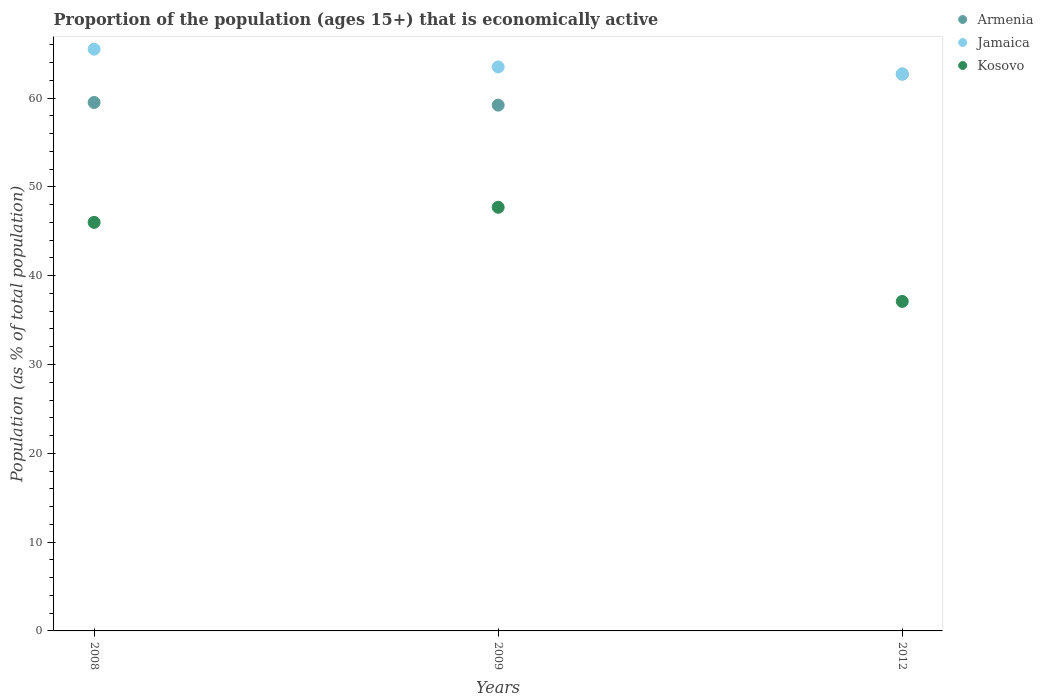What is the proportion of the population that is economically active in Armenia in 2012?
Offer a very short reply. 62.7. Across all years, what is the maximum proportion of the population that is economically active in Jamaica?
Your response must be concise. 65.5. Across all years, what is the minimum proportion of the population that is economically active in Kosovo?
Make the answer very short. 37.1. In which year was the proportion of the population that is economically active in Jamaica maximum?
Keep it short and to the point. 2008. What is the total proportion of the population that is economically active in Jamaica in the graph?
Ensure brevity in your answer.  191.7. What is the difference between the proportion of the population that is economically active in Kosovo in 2008 and that in 2012?
Make the answer very short. 8.9. What is the difference between the proportion of the population that is economically active in Jamaica in 2012 and the proportion of the population that is economically active in Armenia in 2008?
Provide a short and direct response. 3.2. What is the average proportion of the population that is economically active in Armenia per year?
Provide a succinct answer. 60.47. What is the ratio of the proportion of the population that is economically active in Armenia in 2009 to that in 2012?
Make the answer very short. 0.94. Is the proportion of the population that is economically active in Kosovo in 2008 less than that in 2009?
Make the answer very short. Yes. What is the difference between the highest and the second highest proportion of the population that is economically active in Armenia?
Give a very brief answer. 3.2. What is the difference between the highest and the lowest proportion of the population that is economically active in Kosovo?
Provide a succinct answer. 10.6. Is it the case that in every year, the sum of the proportion of the population that is economically active in Armenia and proportion of the population that is economically active in Jamaica  is greater than the proportion of the population that is economically active in Kosovo?
Keep it short and to the point. Yes. Does the proportion of the population that is economically active in Kosovo monotonically increase over the years?
Offer a very short reply. No. What is the difference between two consecutive major ticks on the Y-axis?
Your answer should be very brief. 10. Are the values on the major ticks of Y-axis written in scientific E-notation?
Offer a very short reply. No. Does the graph contain any zero values?
Offer a terse response. No. How many legend labels are there?
Provide a short and direct response. 3. How are the legend labels stacked?
Your response must be concise. Vertical. What is the title of the graph?
Provide a succinct answer. Proportion of the population (ages 15+) that is economically active. What is the label or title of the Y-axis?
Give a very brief answer. Population (as % of total population). What is the Population (as % of total population) in Armenia in 2008?
Provide a succinct answer. 59.5. What is the Population (as % of total population) of Jamaica in 2008?
Offer a very short reply. 65.5. What is the Population (as % of total population) of Armenia in 2009?
Keep it short and to the point. 59.2. What is the Population (as % of total population) in Jamaica in 2009?
Ensure brevity in your answer.  63.5. What is the Population (as % of total population) of Kosovo in 2009?
Your response must be concise. 47.7. What is the Population (as % of total population) in Armenia in 2012?
Your response must be concise. 62.7. What is the Population (as % of total population) in Jamaica in 2012?
Your answer should be compact. 62.7. What is the Population (as % of total population) in Kosovo in 2012?
Ensure brevity in your answer.  37.1. Across all years, what is the maximum Population (as % of total population) of Armenia?
Your response must be concise. 62.7. Across all years, what is the maximum Population (as % of total population) of Jamaica?
Provide a succinct answer. 65.5. Across all years, what is the maximum Population (as % of total population) in Kosovo?
Offer a terse response. 47.7. Across all years, what is the minimum Population (as % of total population) in Armenia?
Your answer should be very brief. 59.2. Across all years, what is the minimum Population (as % of total population) of Jamaica?
Keep it short and to the point. 62.7. Across all years, what is the minimum Population (as % of total population) in Kosovo?
Offer a terse response. 37.1. What is the total Population (as % of total population) of Armenia in the graph?
Keep it short and to the point. 181.4. What is the total Population (as % of total population) of Jamaica in the graph?
Provide a succinct answer. 191.7. What is the total Population (as % of total population) of Kosovo in the graph?
Your answer should be compact. 130.8. What is the difference between the Population (as % of total population) in Jamaica in 2008 and that in 2009?
Keep it short and to the point. 2. What is the difference between the Population (as % of total population) of Kosovo in 2008 and that in 2009?
Provide a short and direct response. -1.7. What is the difference between the Population (as % of total population) in Armenia in 2008 and that in 2012?
Make the answer very short. -3.2. What is the difference between the Population (as % of total population) of Jamaica in 2008 and that in 2012?
Provide a succinct answer. 2.8. What is the difference between the Population (as % of total population) in Kosovo in 2008 and that in 2012?
Give a very brief answer. 8.9. What is the difference between the Population (as % of total population) in Armenia in 2009 and that in 2012?
Offer a terse response. -3.5. What is the difference between the Population (as % of total population) of Kosovo in 2009 and that in 2012?
Provide a succinct answer. 10.6. What is the difference between the Population (as % of total population) in Armenia in 2008 and the Population (as % of total population) in Jamaica in 2009?
Provide a short and direct response. -4. What is the difference between the Population (as % of total population) in Armenia in 2008 and the Population (as % of total population) in Jamaica in 2012?
Make the answer very short. -3.2. What is the difference between the Population (as % of total population) of Armenia in 2008 and the Population (as % of total population) of Kosovo in 2012?
Provide a short and direct response. 22.4. What is the difference between the Population (as % of total population) in Jamaica in 2008 and the Population (as % of total population) in Kosovo in 2012?
Your response must be concise. 28.4. What is the difference between the Population (as % of total population) in Armenia in 2009 and the Population (as % of total population) in Jamaica in 2012?
Your answer should be very brief. -3.5. What is the difference between the Population (as % of total population) in Armenia in 2009 and the Population (as % of total population) in Kosovo in 2012?
Your answer should be compact. 22.1. What is the difference between the Population (as % of total population) of Jamaica in 2009 and the Population (as % of total population) of Kosovo in 2012?
Give a very brief answer. 26.4. What is the average Population (as % of total population) of Armenia per year?
Ensure brevity in your answer.  60.47. What is the average Population (as % of total population) in Jamaica per year?
Your answer should be very brief. 63.9. What is the average Population (as % of total population) of Kosovo per year?
Make the answer very short. 43.6. In the year 2008, what is the difference between the Population (as % of total population) in Armenia and Population (as % of total population) in Jamaica?
Offer a terse response. -6. In the year 2008, what is the difference between the Population (as % of total population) in Armenia and Population (as % of total population) in Kosovo?
Your answer should be compact. 13.5. In the year 2008, what is the difference between the Population (as % of total population) of Jamaica and Population (as % of total population) of Kosovo?
Your response must be concise. 19.5. In the year 2009, what is the difference between the Population (as % of total population) of Armenia and Population (as % of total population) of Jamaica?
Your answer should be compact. -4.3. In the year 2009, what is the difference between the Population (as % of total population) of Armenia and Population (as % of total population) of Kosovo?
Give a very brief answer. 11.5. In the year 2009, what is the difference between the Population (as % of total population) in Jamaica and Population (as % of total population) in Kosovo?
Make the answer very short. 15.8. In the year 2012, what is the difference between the Population (as % of total population) in Armenia and Population (as % of total population) in Jamaica?
Make the answer very short. 0. In the year 2012, what is the difference between the Population (as % of total population) in Armenia and Population (as % of total population) in Kosovo?
Provide a succinct answer. 25.6. In the year 2012, what is the difference between the Population (as % of total population) in Jamaica and Population (as % of total population) in Kosovo?
Make the answer very short. 25.6. What is the ratio of the Population (as % of total population) of Armenia in 2008 to that in 2009?
Make the answer very short. 1.01. What is the ratio of the Population (as % of total population) in Jamaica in 2008 to that in 2009?
Provide a succinct answer. 1.03. What is the ratio of the Population (as % of total population) in Kosovo in 2008 to that in 2009?
Provide a short and direct response. 0.96. What is the ratio of the Population (as % of total population) of Armenia in 2008 to that in 2012?
Your answer should be compact. 0.95. What is the ratio of the Population (as % of total population) of Jamaica in 2008 to that in 2012?
Ensure brevity in your answer.  1.04. What is the ratio of the Population (as % of total population) in Kosovo in 2008 to that in 2012?
Ensure brevity in your answer.  1.24. What is the ratio of the Population (as % of total population) in Armenia in 2009 to that in 2012?
Give a very brief answer. 0.94. What is the ratio of the Population (as % of total population) in Jamaica in 2009 to that in 2012?
Your answer should be very brief. 1.01. What is the difference between the highest and the second highest Population (as % of total population) in Jamaica?
Offer a very short reply. 2. What is the difference between the highest and the lowest Population (as % of total population) of Kosovo?
Provide a short and direct response. 10.6. 